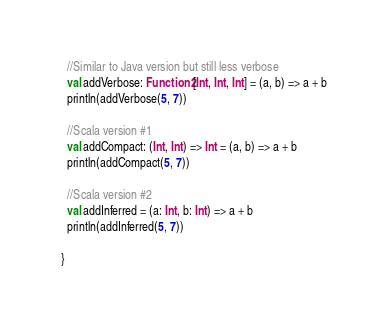Convert code to text. <code><loc_0><loc_0><loc_500><loc_500><_Scala_>  //Similar to Java version but still less verbose
  val addVerbose: Function2[Int, Int, Int] = (a, b) => a + b
  println(addVerbose(5, 7))

  //Scala version #1
  val addCompact: (Int, Int) => Int = (a, b) => a + b
  println(addCompact(5, 7))

  //Scala version #2
  val addInferred = (a: Int, b: Int) => a + b
  println(addInferred(5, 7))

}
</code> 